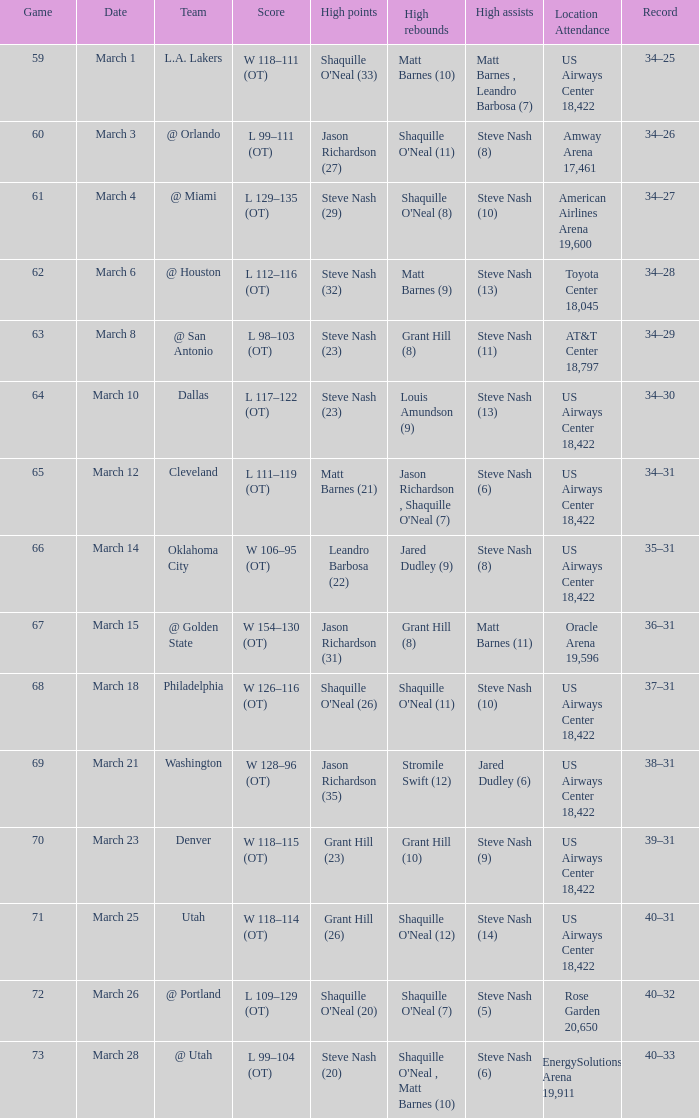After the march 15 contest, what was the team's performance? 36–31. 